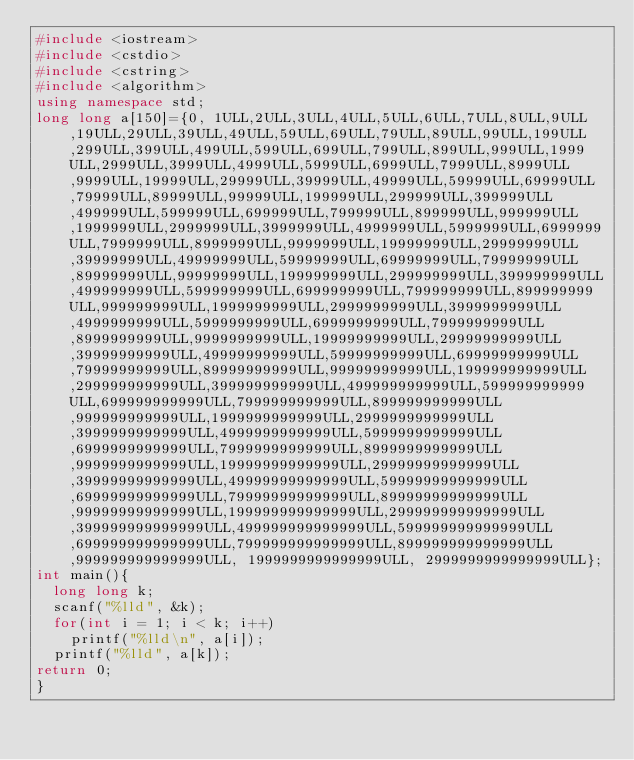Convert code to text. <code><loc_0><loc_0><loc_500><loc_500><_C++_>#include <iostream>
#include <cstdio>
#include <cstring>
#include <algorithm>
using namespace std;
long long a[150]={0, 1ULL,2ULL,3ULL,4ULL,5ULL,6ULL,7ULL,8ULL,9ULL,19ULL,29ULL,39ULL,49ULL,59ULL,69ULL,79ULL,89ULL,99ULL,199ULL,299ULL,399ULL,499ULL,599ULL,699ULL,799ULL,899ULL,999ULL,1999ULL,2999ULL,3999ULL,4999ULL,5999ULL,6999ULL,7999ULL,8999ULL,9999ULL,19999ULL,29999ULL,39999ULL,49999ULL,59999ULL,69999ULL,79999ULL,89999ULL,99999ULL,199999ULL,299999ULL,399999ULL,499999ULL,599999ULL,699999ULL,799999ULL,899999ULL,999999ULL,1999999ULL,2999999ULL,3999999ULL,4999999ULL,5999999ULL,6999999ULL,7999999ULL,8999999ULL,9999999ULL,19999999ULL,29999999ULL,39999999ULL,49999999ULL,59999999ULL,69999999ULL,79999999ULL,89999999ULL,99999999ULL,199999999ULL,299999999ULL,399999999ULL,499999999ULL,599999999ULL,699999999ULL,799999999ULL,899999999ULL,999999999ULL,1999999999ULL,2999999999ULL,3999999999ULL,4999999999ULL,5999999999ULL,6999999999ULL,7999999999ULL,8999999999ULL,9999999999ULL,19999999999ULL,29999999999ULL,39999999999ULL,49999999999ULL,59999999999ULL,69999999999ULL,79999999999ULL,89999999999ULL,99999999999ULL,199999999999ULL,299999999999ULL,399999999999ULL,499999999999ULL,599999999999ULL,699999999999ULL,799999999999ULL,899999999999ULL,999999999999ULL,1999999999999ULL,2999999999999ULL,3999999999999ULL,4999999999999ULL,5999999999999ULL,6999999999999ULL,7999999999999ULL,8999999999999ULL,9999999999999ULL,19999999999999ULL,29999999999999ULL,39999999999999ULL,49999999999999ULL,59999999999999ULL,69999999999999ULL,79999999999999ULL,89999999999999ULL,99999999999999ULL,199999999999999ULL,299999999999999ULL,399999999999999ULL,499999999999999ULL,599999999999999ULL,699999999999999ULL,799999999999999ULL,899999999999999ULL,999999999999999ULL, 1999999999999999ULL, 2999999999999999ULL};
int main(){
	long long k;
	scanf("%lld", &k);
	for(int i = 1; i < k; i++)
		printf("%lld\n", a[i]);
	printf("%lld", a[k]);
return 0;
}</code> 